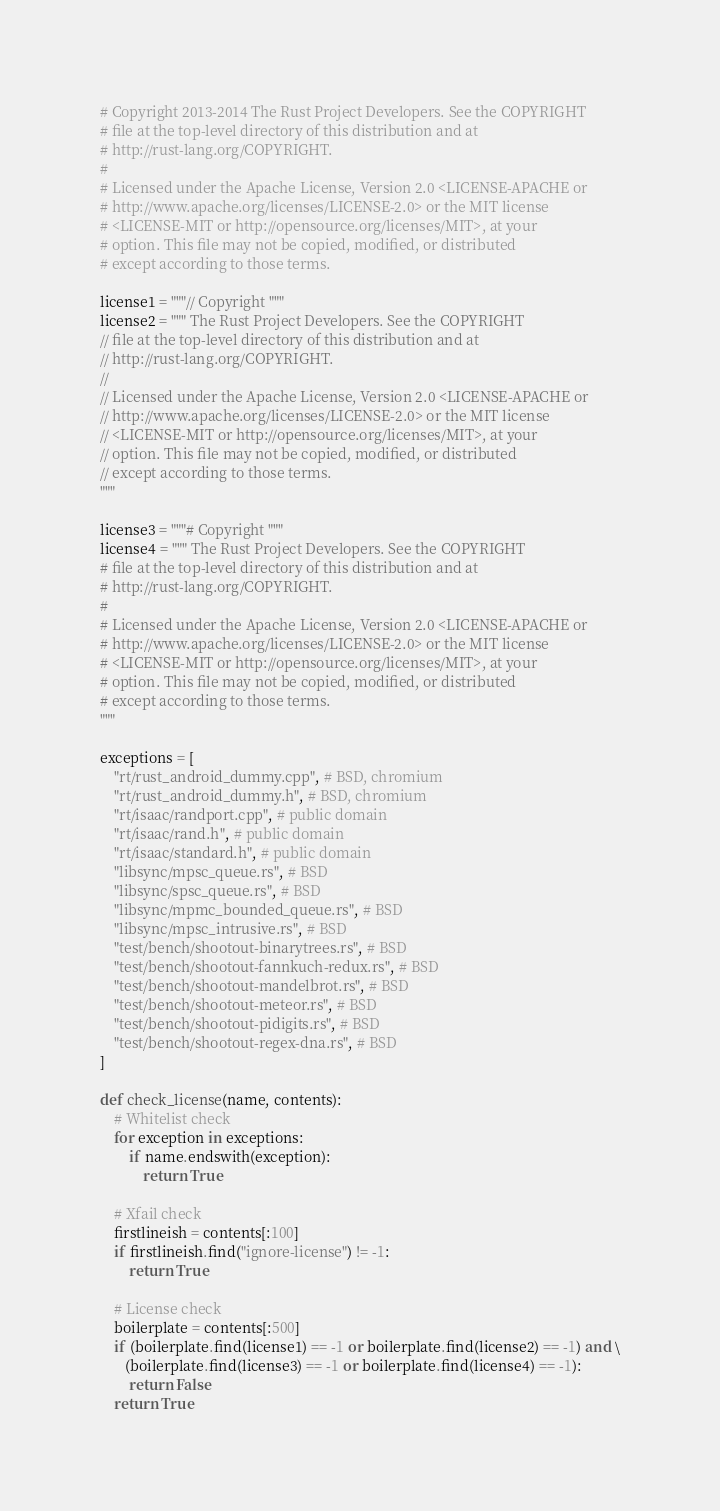<code> <loc_0><loc_0><loc_500><loc_500><_Python_># Copyright 2013-2014 The Rust Project Developers. See the COPYRIGHT
# file at the top-level directory of this distribution and at
# http://rust-lang.org/COPYRIGHT.
#
# Licensed under the Apache License, Version 2.0 <LICENSE-APACHE or
# http://www.apache.org/licenses/LICENSE-2.0> or the MIT license
# <LICENSE-MIT or http://opensource.org/licenses/MIT>, at your
# option. This file may not be copied, modified, or distributed
# except according to those terms.

license1 = """// Copyright """
license2 = """ The Rust Project Developers. See the COPYRIGHT
// file at the top-level directory of this distribution and at
// http://rust-lang.org/COPYRIGHT.
//
// Licensed under the Apache License, Version 2.0 <LICENSE-APACHE or
// http://www.apache.org/licenses/LICENSE-2.0> or the MIT license
// <LICENSE-MIT or http://opensource.org/licenses/MIT>, at your
// option. This file may not be copied, modified, or distributed
// except according to those terms.
"""

license3 = """# Copyright """
license4 = """ The Rust Project Developers. See the COPYRIGHT
# file at the top-level directory of this distribution and at
# http://rust-lang.org/COPYRIGHT.
#
# Licensed under the Apache License, Version 2.0 <LICENSE-APACHE or
# http://www.apache.org/licenses/LICENSE-2.0> or the MIT license
# <LICENSE-MIT or http://opensource.org/licenses/MIT>, at your
# option. This file may not be copied, modified, or distributed
# except according to those terms.
"""

exceptions = [
    "rt/rust_android_dummy.cpp", # BSD, chromium
    "rt/rust_android_dummy.h", # BSD, chromium
    "rt/isaac/randport.cpp", # public domain
    "rt/isaac/rand.h", # public domain
    "rt/isaac/standard.h", # public domain
    "libsync/mpsc_queue.rs", # BSD
    "libsync/spsc_queue.rs", # BSD
    "libsync/mpmc_bounded_queue.rs", # BSD
    "libsync/mpsc_intrusive.rs", # BSD
    "test/bench/shootout-binarytrees.rs", # BSD
    "test/bench/shootout-fannkuch-redux.rs", # BSD
    "test/bench/shootout-mandelbrot.rs", # BSD
    "test/bench/shootout-meteor.rs", # BSD
    "test/bench/shootout-pidigits.rs", # BSD
    "test/bench/shootout-regex-dna.rs", # BSD
]

def check_license(name, contents):
    # Whitelist check
    for exception in exceptions:
        if name.endswith(exception):
            return True

    # Xfail check
    firstlineish = contents[:100]
    if firstlineish.find("ignore-license") != -1:
        return True

    # License check
    boilerplate = contents[:500]
    if (boilerplate.find(license1) == -1 or boilerplate.find(license2) == -1) and \
       (boilerplate.find(license3) == -1 or boilerplate.find(license4) == -1):
        return False
    return True
</code> 